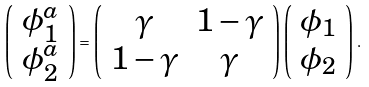Convert formula to latex. <formula><loc_0><loc_0><loc_500><loc_500>\left ( \begin{array} { c } \phi ^ { a } _ { 1 } \\ \phi ^ { a } _ { 2 } \end{array} \right ) = \left ( \begin{array} { c c } \gamma & 1 - \gamma \\ 1 - \gamma & \gamma \end{array} \right ) \left ( \begin{array} { c } \phi _ { 1 } \\ \phi _ { 2 } \end{array} \right ) \, .</formula> 